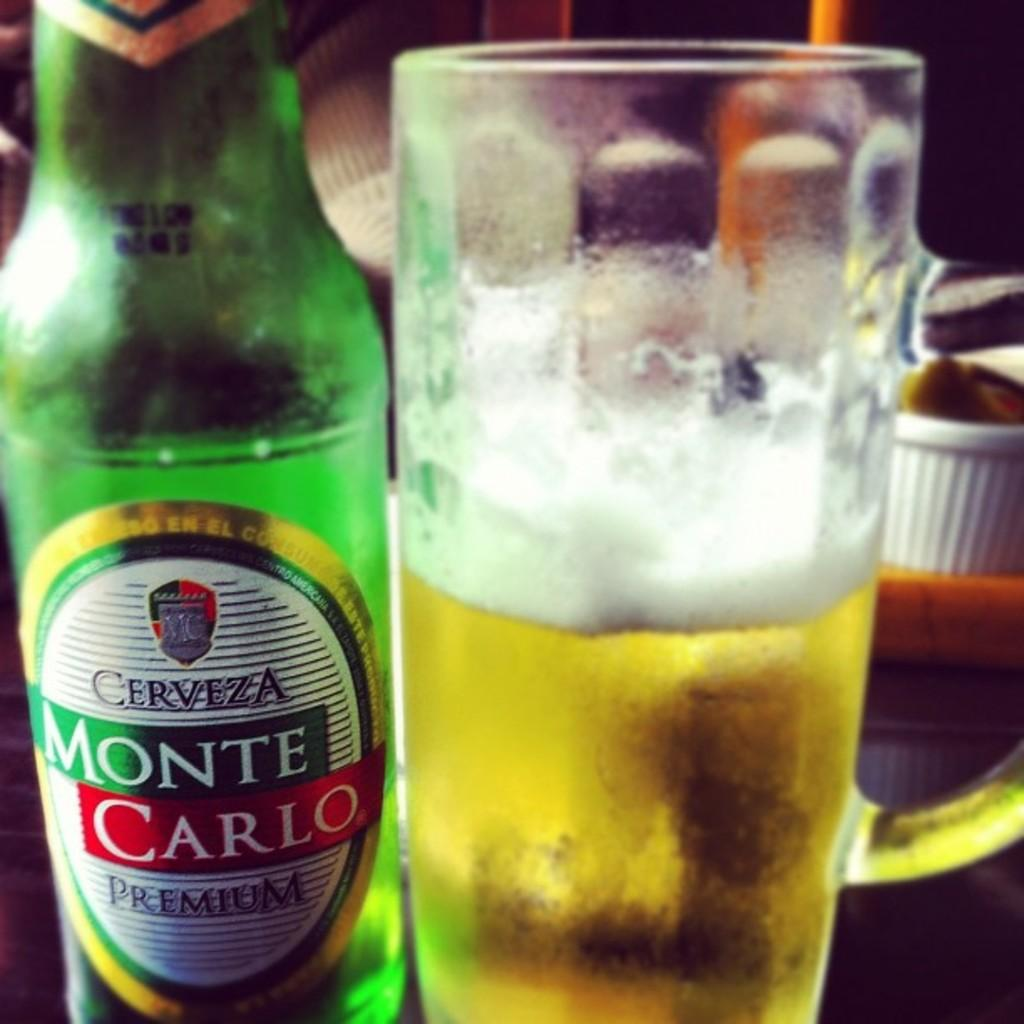<image>
Write a terse but informative summary of the picture. A bottle of Monte Carlo beer is to the left of a half empty mug of beer. 